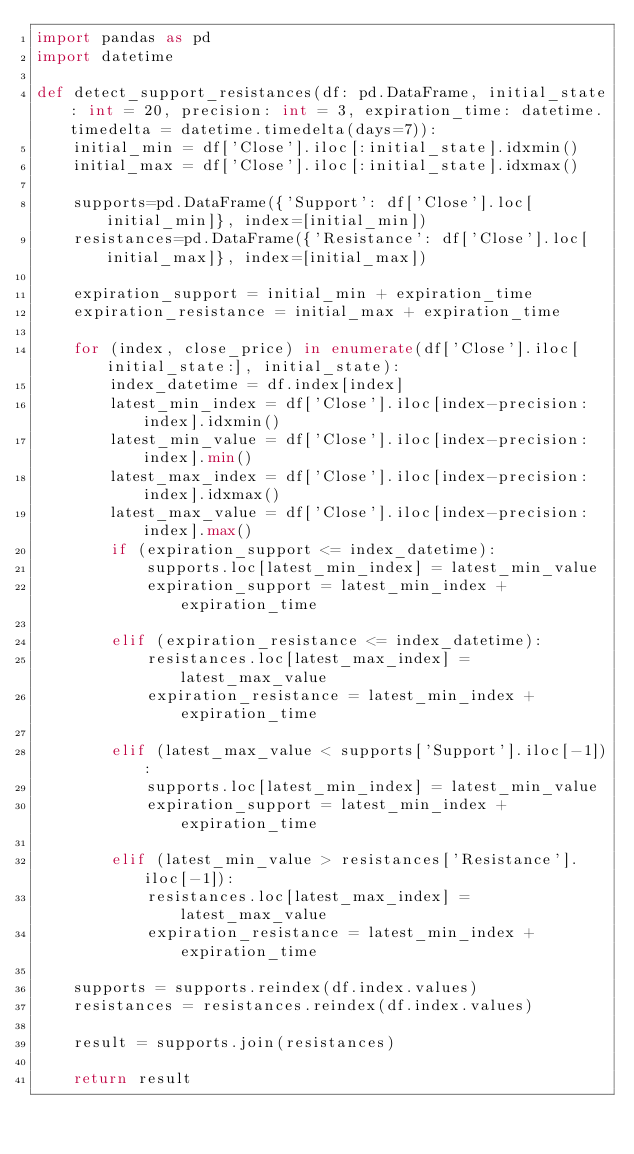Convert code to text. <code><loc_0><loc_0><loc_500><loc_500><_Python_>import pandas as pd
import datetime

def detect_support_resistances(df: pd.DataFrame, initial_state: int = 20, precision: int = 3, expiration_time: datetime.timedelta = datetime.timedelta(days=7)):
    initial_min = df['Close'].iloc[:initial_state].idxmin()
    initial_max = df['Close'].iloc[:initial_state].idxmax()

    supports=pd.DataFrame({'Support': df['Close'].loc[initial_min]}, index=[initial_min])
    resistances=pd.DataFrame({'Resistance': df['Close'].loc[initial_max]}, index=[initial_max])

    expiration_support = initial_min + expiration_time
    expiration_resistance = initial_max + expiration_time

    for (index, close_price) in enumerate(df['Close'].iloc[initial_state:], initial_state):
        index_datetime = df.index[index]
        latest_min_index = df['Close'].iloc[index-precision:index].idxmin()
        latest_min_value = df['Close'].iloc[index-precision:index].min()
        latest_max_index = df['Close'].iloc[index-precision:index].idxmax()
        latest_max_value = df['Close'].iloc[index-precision:index].max()
        if (expiration_support <= index_datetime):
            supports.loc[latest_min_index] = latest_min_value
            expiration_support = latest_min_index + expiration_time

        elif (expiration_resistance <= index_datetime):
            resistances.loc[latest_max_index] =latest_max_value
            expiration_resistance = latest_min_index + expiration_time

        elif (latest_max_value < supports['Support'].iloc[-1]):
            supports.loc[latest_min_index] = latest_min_value
            expiration_support = latest_min_index + expiration_time

        elif (latest_min_value > resistances['Resistance'].iloc[-1]):
            resistances.loc[latest_max_index] = latest_max_value
            expiration_resistance = latest_min_index + expiration_time

    supports = supports.reindex(df.index.values)
    resistances = resistances.reindex(df.index.values)

    result = supports.join(resistances)

    return result</code> 